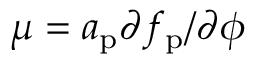<formula> <loc_0><loc_0><loc_500><loc_500>\mu = a _ { p } \partial f _ { p } / \partial \phi</formula> 